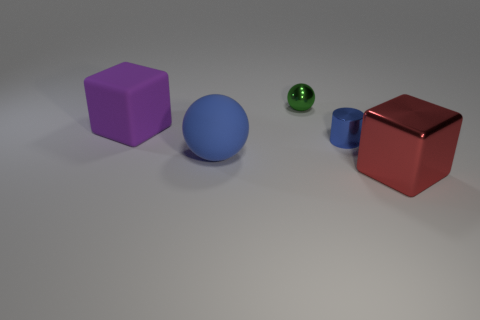Add 5 tiny yellow blocks. How many objects exist? 10 Subtract all balls. How many objects are left? 3 Add 4 tiny red rubber objects. How many tiny red rubber objects exist? 4 Subtract 0 brown cylinders. How many objects are left? 5 Subtract all large cyan shiny spheres. Subtract all large red metallic objects. How many objects are left? 4 Add 3 blue matte balls. How many blue matte balls are left? 4 